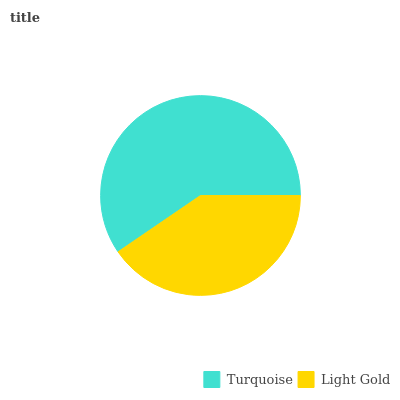Is Light Gold the minimum?
Answer yes or no. Yes. Is Turquoise the maximum?
Answer yes or no. Yes. Is Light Gold the maximum?
Answer yes or no. No. Is Turquoise greater than Light Gold?
Answer yes or no. Yes. Is Light Gold less than Turquoise?
Answer yes or no. Yes. Is Light Gold greater than Turquoise?
Answer yes or no. No. Is Turquoise less than Light Gold?
Answer yes or no. No. Is Turquoise the high median?
Answer yes or no. Yes. Is Light Gold the low median?
Answer yes or no. Yes. Is Light Gold the high median?
Answer yes or no. No. Is Turquoise the low median?
Answer yes or no. No. 